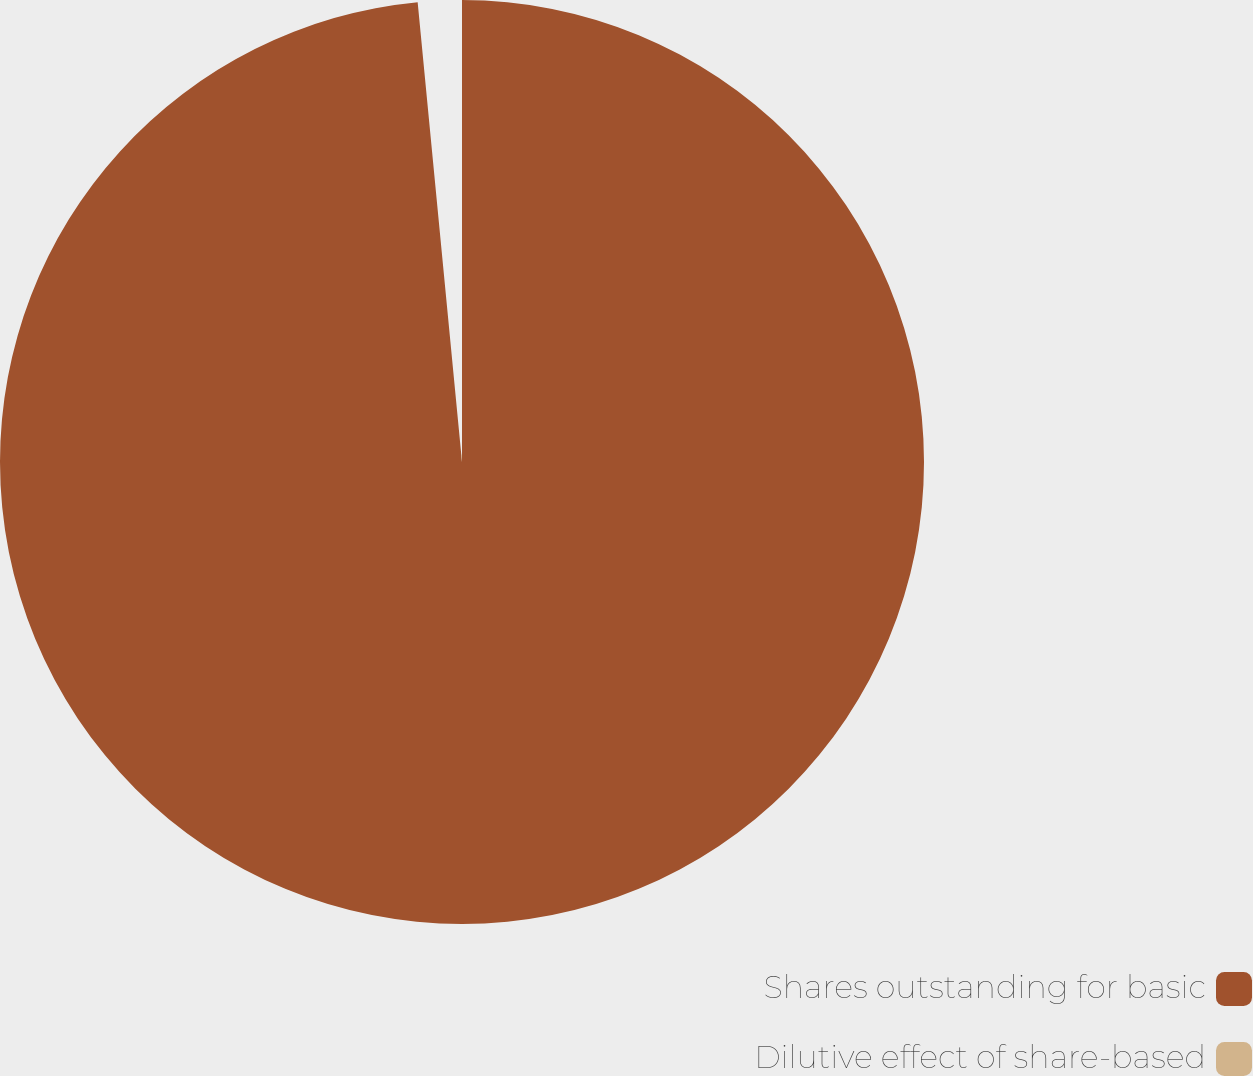<chart> <loc_0><loc_0><loc_500><loc_500><pie_chart><fcel>Shares outstanding for basic<fcel>Dilutive effect of share-based<nl><fcel>98.47%<fcel>1.53%<nl></chart> 